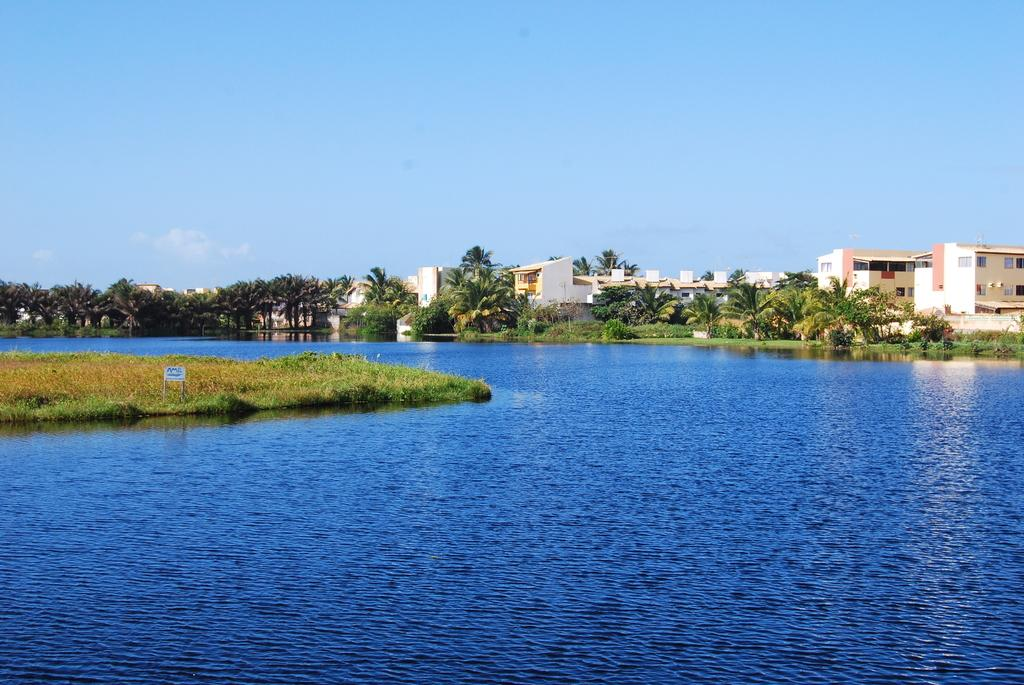What type of vegetation is present in the image? There are many trees in the image. What type of structures can be seen in the image? There are buildings in the image. What type of ground cover is visible in the image? There is grass visible in the image. What type of information might be conveyed by the sign board in the image? The sign board in the image might convey information about directions, locations, or events. What type of natural feature is visible in the image? There is water visible in the image. What is visible at the top of the image? The sky is visible at the top of the image. How many thumbs are visible in the image? There are no thumbs visible in the image. What type of learning material is present in the image? There is no learning material present in the image. 